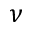<formula> <loc_0><loc_0><loc_500><loc_500>\nu</formula> 